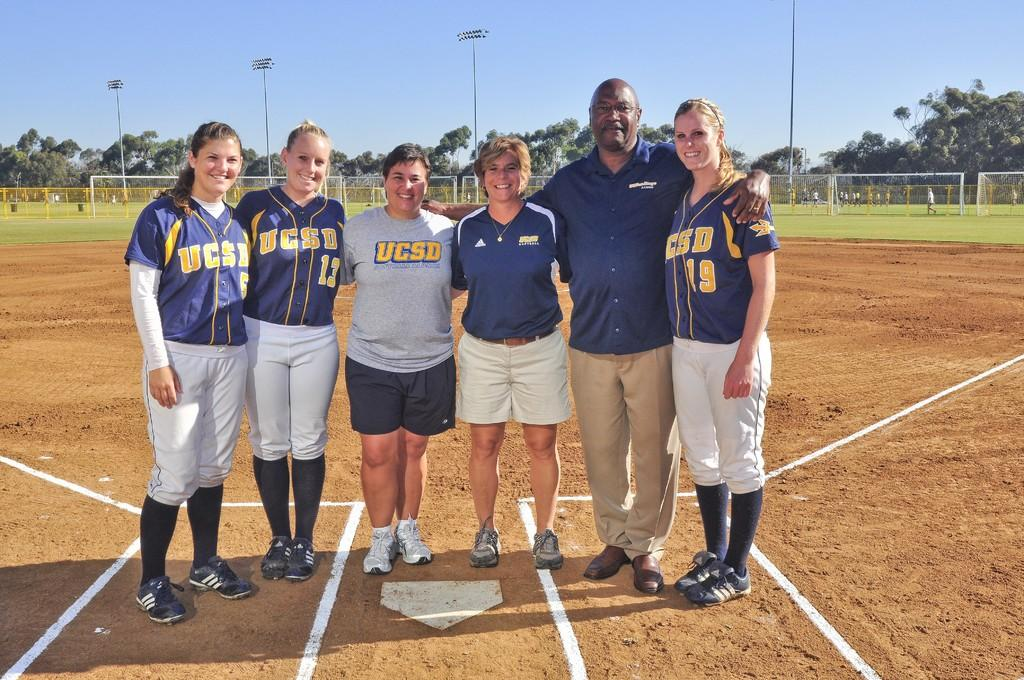<image>
Write a terse but informative summary of the picture. USCD players #19, #13 and #5 pose with coaches for a phote on home base. 